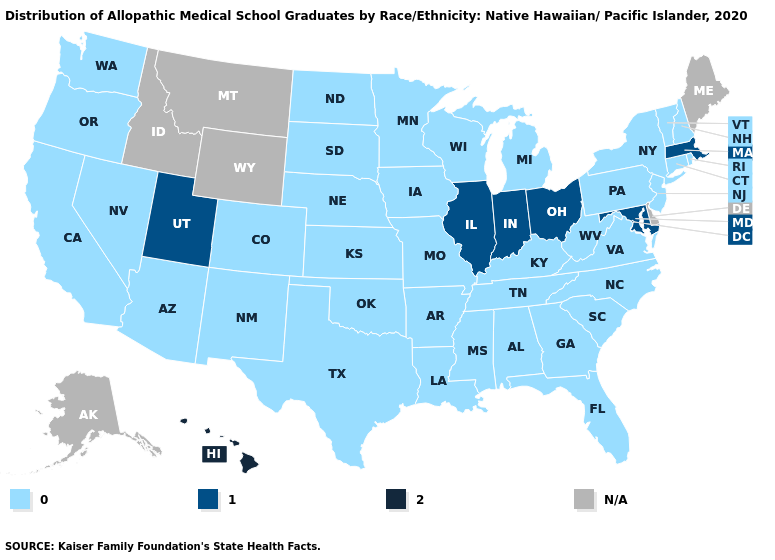What is the value of Pennsylvania?
Keep it brief. 0.0. What is the value of North Dakota?
Be succinct. 0.0. Name the states that have a value in the range 1.0?
Be succinct. Illinois, Indiana, Maryland, Massachusetts, Ohio, Utah. What is the lowest value in states that border Florida?
Quick response, please. 0.0. Name the states that have a value in the range 2.0?
Quick response, please. Hawaii. Does Indiana have the highest value in the MidWest?
Write a very short answer. Yes. How many symbols are there in the legend?
Give a very brief answer. 4. What is the value of Connecticut?
Write a very short answer. 0.0. Name the states that have a value in the range 0.0?
Write a very short answer. Alabama, Arizona, Arkansas, California, Colorado, Connecticut, Florida, Georgia, Iowa, Kansas, Kentucky, Louisiana, Michigan, Minnesota, Mississippi, Missouri, Nebraska, Nevada, New Hampshire, New Jersey, New Mexico, New York, North Carolina, North Dakota, Oklahoma, Oregon, Pennsylvania, Rhode Island, South Carolina, South Dakota, Tennessee, Texas, Vermont, Virginia, Washington, West Virginia, Wisconsin. Does Massachusetts have the lowest value in the Northeast?
Give a very brief answer. No. What is the lowest value in the MidWest?
Answer briefly. 0.0. Name the states that have a value in the range 2.0?
Quick response, please. Hawaii. What is the value of Colorado?
Answer briefly. 0.0. Which states have the highest value in the USA?
Quick response, please. Hawaii. What is the value of Alaska?
Concise answer only. N/A. 